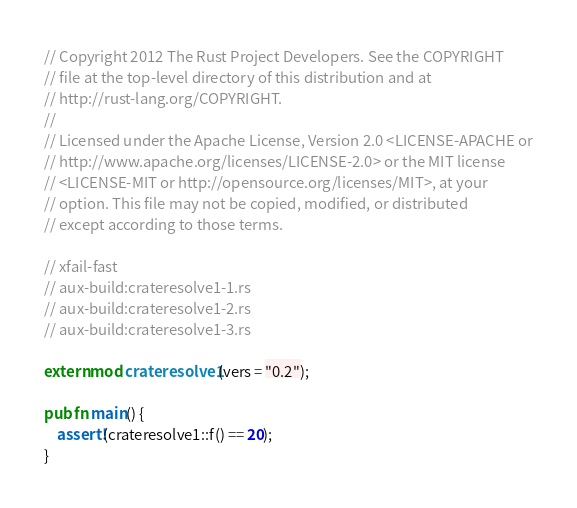<code> <loc_0><loc_0><loc_500><loc_500><_Rust_>// Copyright 2012 The Rust Project Developers. See the COPYRIGHT
// file at the top-level directory of this distribution and at
// http://rust-lang.org/COPYRIGHT.
//
// Licensed under the Apache License, Version 2.0 <LICENSE-APACHE or
// http://www.apache.org/licenses/LICENSE-2.0> or the MIT license
// <LICENSE-MIT or http://opensource.org/licenses/MIT>, at your
// option. This file may not be copied, modified, or distributed
// except according to those terms.

// xfail-fast
// aux-build:crateresolve1-1.rs
// aux-build:crateresolve1-2.rs
// aux-build:crateresolve1-3.rs

extern mod crateresolve1(vers = "0.2");

pub fn main() {
    assert!(crateresolve1::f() == 20);
}
</code> 